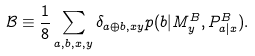Convert formula to latex. <formula><loc_0><loc_0><loc_500><loc_500>\mathcal { B } \equiv \frac { 1 } { 8 } \sum _ { a , b , x , y } \delta _ { a \oplus b , x y } p ( b | M ^ { B } _ { y } , P ^ { B } _ { a | x } ) .</formula> 